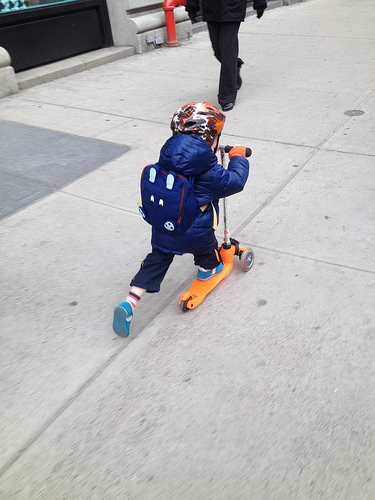<image>
Is there a kid in the road? No. The kid is not contained within the road. These objects have a different spatial relationship. Is the kid on the scooter? Yes. Looking at the image, I can see the kid is positioned on top of the scooter, with the scooter providing support. 